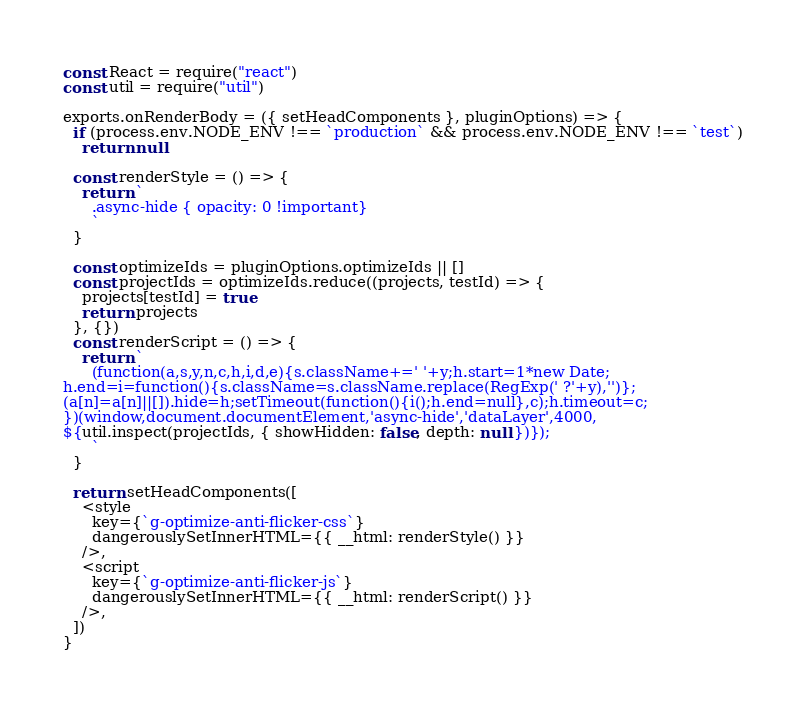Convert code to text. <code><loc_0><loc_0><loc_500><loc_500><_JavaScript_>const React = require("react")
const util = require("util")

exports.onRenderBody = ({ setHeadComponents }, pluginOptions) => {
  if (process.env.NODE_ENV !== `production` && process.env.NODE_ENV !== `test`)
    return null

  const renderStyle = () => {
    return `
      .async-hide { opacity: 0 !important}
      `
  }

  const optimizeIds = pluginOptions.optimizeIds || []
  const projectIds = optimizeIds.reduce((projects, testId) => {
    projects[testId] = true
    return projects
  }, {})
  const renderScript = () => {
    return `
      (function(a,s,y,n,c,h,i,d,e){s.className+=' '+y;h.start=1*new Date;
h.end=i=function(){s.className=s.className.replace(RegExp(' ?'+y),'')};
(a[n]=a[n]||[]).hide=h;setTimeout(function(){i();h.end=null},c);h.timeout=c;
})(window,document.documentElement,'async-hide','dataLayer',4000,
${util.inspect(projectIds, { showHidden: false, depth: null })});
      `
  }

  return setHeadComponents([
    <style
      key={`g-optimize-anti-flicker-css`}
      dangerouslySetInnerHTML={{ __html: renderStyle() }}
    />,
    <script
      key={`g-optimize-anti-flicker-js`}
      dangerouslySetInnerHTML={{ __html: renderScript() }}
    />,
  ])
}
</code> 